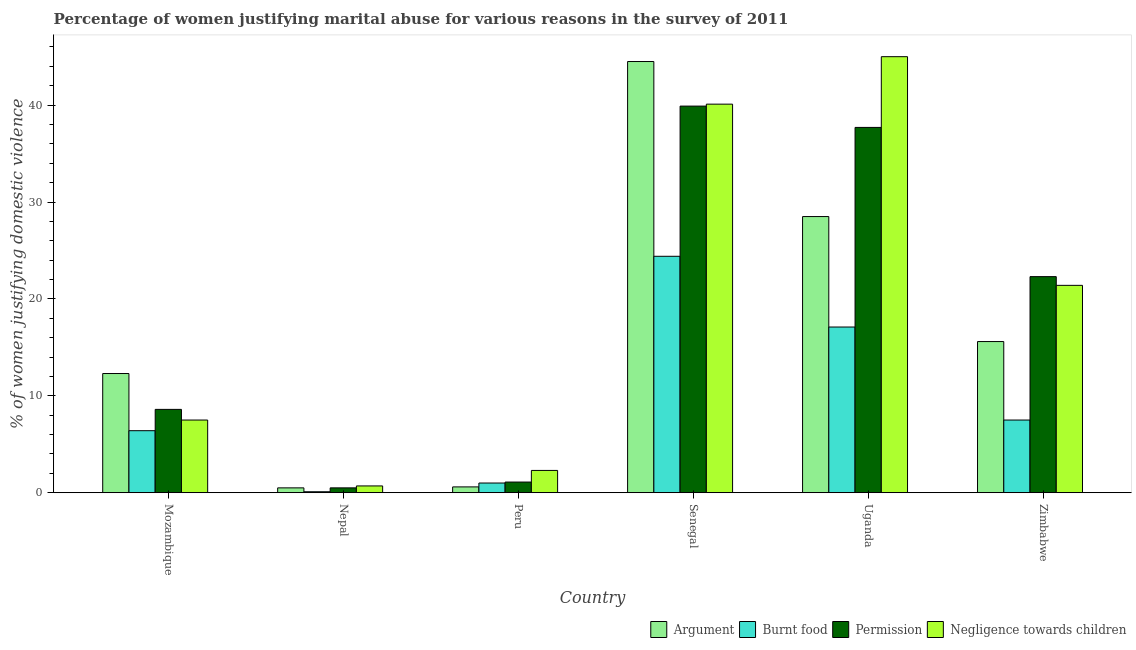Are the number of bars on each tick of the X-axis equal?
Provide a succinct answer. Yes. What is the label of the 5th group of bars from the left?
Provide a short and direct response. Uganda. In how many cases, is the number of bars for a given country not equal to the number of legend labels?
Give a very brief answer. 0. What is the percentage of women justifying abuse for burning food in Nepal?
Provide a succinct answer. 0.1. Across all countries, what is the minimum percentage of women justifying abuse for showing negligence towards children?
Provide a short and direct response. 0.7. In which country was the percentage of women justifying abuse for showing negligence towards children maximum?
Your response must be concise. Uganda. In which country was the percentage of women justifying abuse for burning food minimum?
Offer a very short reply. Nepal. What is the total percentage of women justifying abuse for showing negligence towards children in the graph?
Keep it short and to the point. 117. What is the difference between the percentage of women justifying abuse for burning food in Uganda and that in Zimbabwe?
Ensure brevity in your answer.  9.6. What is the difference between the percentage of women justifying abuse for burning food in Uganda and the percentage of women justifying abuse for showing negligence towards children in Zimbabwe?
Your response must be concise. -4.3. What is the average percentage of women justifying abuse for going without permission per country?
Provide a short and direct response. 18.35. In how many countries, is the percentage of women justifying abuse for going without permission greater than 6 %?
Offer a very short reply. 4. What is the ratio of the percentage of women justifying abuse in the case of an argument in Nepal to that in Uganda?
Your response must be concise. 0.02. Is the difference between the percentage of women justifying abuse for burning food in Uganda and Zimbabwe greater than the difference between the percentage of women justifying abuse in the case of an argument in Uganda and Zimbabwe?
Your answer should be compact. No. What is the difference between the highest and the second highest percentage of women justifying abuse for showing negligence towards children?
Your answer should be very brief. 4.9. What is the difference between the highest and the lowest percentage of women justifying abuse for showing negligence towards children?
Offer a very short reply. 44.3. Is it the case that in every country, the sum of the percentage of women justifying abuse for going without permission and percentage of women justifying abuse for showing negligence towards children is greater than the sum of percentage of women justifying abuse in the case of an argument and percentage of women justifying abuse for burning food?
Make the answer very short. No. What does the 3rd bar from the left in Peru represents?
Make the answer very short. Permission. What does the 2nd bar from the right in Peru represents?
Provide a short and direct response. Permission. Is it the case that in every country, the sum of the percentage of women justifying abuse in the case of an argument and percentage of women justifying abuse for burning food is greater than the percentage of women justifying abuse for going without permission?
Offer a terse response. Yes. How many bars are there?
Ensure brevity in your answer.  24. Are all the bars in the graph horizontal?
Your answer should be very brief. No. Where does the legend appear in the graph?
Offer a terse response. Bottom right. What is the title of the graph?
Your answer should be very brief. Percentage of women justifying marital abuse for various reasons in the survey of 2011. What is the label or title of the Y-axis?
Your response must be concise. % of women justifying domestic violence. What is the % of women justifying domestic violence in Burnt food in Mozambique?
Ensure brevity in your answer.  6.4. What is the % of women justifying domestic violence in Permission in Mozambique?
Give a very brief answer. 8.6. What is the % of women justifying domestic violence of Argument in Nepal?
Give a very brief answer. 0.5. What is the % of women justifying domestic violence in Permission in Nepal?
Offer a very short reply. 0.5. What is the % of women justifying domestic violence of Argument in Peru?
Your answer should be very brief. 0.6. What is the % of women justifying domestic violence of Permission in Peru?
Keep it short and to the point. 1.1. What is the % of women justifying domestic violence in Negligence towards children in Peru?
Offer a terse response. 2.3. What is the % of women justifying domestic violence in Argument in Senegal?
Offer a terse response. 44.5. What is the % of women justifying domestic violence in Burnt food in Senegal?
Provide a succinct answer. 24.4. What is the % of women justifying domestic violence in Permission in Senegal?
Keep it short and to the point. 39.9. What is the % of women justifying domestic violence of Negligence towards children in Senegal?
Offer a very short reply. 40.1. What is the % of women justifying domestic violence of Argument in Uganda?
Your response must be concise. 28.5. What is the % of women justifying domestic violence in Permission in Uganda?
Your response must be concise. 37.7. What is the % of women justifying domestic violence of Argument in Zimbabwe?
Give a very brief answer. 15.6. What is the % of women justifying domestic violence in Permission in Zimbabwe?
Provide a succinct answer. 22.3. What is the % of women justifying domestic violence of Negligence towards children in Zimbabwe?
Your response must be concise. 21.4. Across all countries, what is the maximum % of women justifying domestic violence in Argument?
Give a very brief answer. 44.5. Across all countries, what is the maximum % of women justifying domestic violence in Burnt food?
Your response must be concise. 24.4. Across all countries, what is the maximum % of women justifying domestic violence of Permission?
Keep it short and to the point. 39.9. Across all countries, what is the maximum % of women justifying domestic violence of Negligence towards children?
Provide a short and direct response. 45. Across all countries, what is the minimum % of women justifying domestic violence of Argument?
Provide a short and direct response. 0.5. Across all countries, what is the minimum % of women justifying domestic violence in Burnt food?
Give a very brief answer. 0.1. Across all countries, what is the minimum % of women justifying domestic violence in Permission?
Offer a terse response. 0.5. Across all countries, what is the minimum % of women justifying domestic violence in Negligence towards children?
Ensure brevity in your answer.  0.7. What is the total % of women justifying domestic violence in Argument in the graph?
Keep it short and to the point. 102. What is the total % of women justifying domestic violence of Burnt food in the graph?
Your response must be concise. 56.5. What is the total % of women justifying domestic violence in Permission in the graph?
Give a very brief answer. 110.1. What is the total % of women justifying domestic violence of Negligence towards children in the graph?
Provide a succinct answer. 117. What is the difference between the % of women justifying domestic violence of Burnt food in Mozambique and that in Nepal?
Offer a very short reply. 6.3. What is the difference between the % of women justifying domestic violence in Permission in Mozambique and that in Nepal?
Your response must be concise. 8.1. What is the difference between the % of women justifying domestic violence in Burnt food in Mozambique and that in Peru?
Give a very brief answer. 5.4. What is the difference between the % of women justifying domestic violence of Permission in Mozambique and that in Peru?
Your answer should be compact. 7.5. What is the difference between the % of women justifying domestic violence of Argument in Mozambique and that in Senegal?
Provide a short and direct response. -32.2. What is the difference between the % of women justifying domestic violence of Burnt food in Mozambique and that in Senegal?
Provide a short and direct response. -18. What is the difference between the % of women justifying domestic violence in Permission in Mozambique and that in Senegal?
Keep it short and to the point. -31.3. What is the difference between the % of women justifying domestic violence of Negligence towards children in Mozambique and that in Senegal?
Ensure brevity in your answer.  -32.6. What is the difference between the % of women justifying domestic violence of Argument in Mozambique and that in Uganda?
Provide a succinct answer. -16.2. What is the difference between the % of women justifying domestic violence in Permission in Mozambique and that in Uganda?
Provide a succinct answer. -29.1. What is the difference between the % of women justifying domestic violence in Negligence towards children in Mozambique and that in Uganda?
Your response must be concise. -37.5. What is the difference between the % of women justifying domestic violence in Argument in Mozambique and that in Zimbabwe?
Your answer should be very brief. -3.3. What is the difference between the % of women justifying domestic violence of Burnt food in Mozambique and that in Zimbabwe?
Provide a succinct answer. -1.1. What is the difference between the % of women justifying domestic violence of Permission in Mozambique and that in Zimbabwe?
Offer a terse response. -13.7. What is the difference between the % of women justifying domestic violence in Negligence towards children in Mozambique and that in Zimbabwe?
Keep it short and to the point. -13.9. What is the difference between the % of women justifying domestic violence of Burnt food in Nepal and that in Peru?
Your answer should be very brief. -0.9. What is the difference between the % of women justifying domestic violence in Negligence towards children in Nepal and that in Peru?
Your answer should be very brief. -1.6. What is the difference between the % of women justifying domestic violence in Argument in Nepal and that in Senegal?
Your answer should be very brief. -44. What is the difference between the % of women justifying domestic violence in Burnt food in Nepal and that in Senegal?
Give a very brief answer. -24.3. What is the difference between the % of women justifying domestic violence of Permission in Nepal and that in Senegal?
Your response must be concise. -39.4. What is the difference between the % of women justifying domestic violence of Negligence towards children in Nepal and that in Senegal?
Ensure brevity in your answer.  -39.4. What is the difference between the % of women justifying domestic violence of Argument in Nepal and that in Uganda?
Provide a short and direct response. -28. What is the difference between the % of women justifying domestic violence of Permission in Nepal and that in Uganda?
Give a very brief answer. -37.2. What is the difference between the % of women justifying domestic violence of Negligence towards children in Nepal and that in Uganda?
Your answer should be compact. -44.3. What is the difference between the % of women justifying domestic violence in Argument in Nepal and that in Zimbabwe?
Make the answer very short. -15.1. What is the difference between the % of women justifying domestic violence of Burnt food in Nepal and that in Zimbabwe?
Offer a very short reply. -7.4. What is the difference between the % of women justifying domestic violence of Permission in Nepal and that in Zimbabwe?
Make the answer very short. -21.8. What is the difference between the % of women justifying domestic violence in Negligence towards children in Nepal and that in Zimbabwe?
Ensure brevity in your answer.  -20.7. What is the difference between the % of women justifying domestic violence in Argument in Peru and that in Senegal?
Keep it short and to the point. -43.9. What is the difference between the % of women justifying domestic violence of Burnt food in Peru and that in Senegal?
Offer a terse response. -23.4. What is the difference between the % of women justifying domestic violence in Permission in Peru and that in Senegal?
Make the answer very short. -38.8. What is the difference between the % of women justifying domestic violence in Negligence towards children in Peru and that in Senegal?
Your response must be concise. -37.8. What is the difference between the % of women justifying domestic violence in Argument in Peru and that in Uganda?
Provide a succinct answer. -27.9. What is the difference between the % of women justifying domestic violence in Burnt food in Peru and that in Uganda?
Keep it short and to the point. -16.1. What is the difference between the % of women justifying domestic violence of Permission in Peru and that in Uganda?
Make the answer very short. -36.6. What is the difference between the % of women justifying domestic violence of Negligence towards children in Peru and that in Uganda?
Your response must be concise. -42.7. What is the difference between the % of women justifying domestic violence of Permission in Peru and that in Zimbabwe?
Provide a short and direct response. -21.2. What is the difference between the % of women justifying domestic violence in Negligence towards children in Peru and that in Zimbabwe?
Your response must be concise. -19.1. What is the difference between the % of women justifying domestic violence in Argument in Senegal and that in Uganda?
Make the answer very short. 16. What is the difference between the % of women justifying domestic violence in Argument in Senegal and that in Zimbabwe?
Offer a terse response. 28.9. What is the difference between the % of women justifying domestic violence in Permission in Senegal and that in Zimbabwe?
Offer a terse response. 17.6. What is the difference between the % of women justifying domestic violence in Negligence towards children in Senegal and that in Zimbabwe?
Provide a succinct answer. 18.7. What is the difference between the % of women justifying domestic violence of Burnt food in Uganda and that in Zimbabwe?
Make the answer very short. 9.6. What is the difference between the % of women justifying domestic violence of Permission in Uganda and that in Zimbabwe?
Your answer should be compact. 15.4. What is the difference between the % of women justifying domestic violence of Negligence towards children in Uganda and that in Zimbabwe?
Offer a terse response. 23.6. What is the difference between the % of women justifying domestic violence of Permission in Mozambique and the % of women justifying domestic violence of Negligence towards children in Nepal?
Provide a succinct answer. 7.9. What is the difference between the % of women justifying domestic violence in Argument in Mozambique and the % of women justifying domestic violence in Burnt food in Peru?
Your response must be concise. 11.3. What is the difference between the % of women justifying domestic violence in Permission in Mozambique and the % of women justifying domestic violence in Negligence towards children in Peru?
Provide a short and direct response. 6.3. What is the difference between the % of women justifying domestic violence in Argument in Mozambique and the % of women justifying domestic violence in Burnt food in Senegal?
Your answer should be very brief. -12.1. What is the difference between the % of women justifying domestic violence of Argument in Mozambique and the % of women justifying domestic violence of Permission in Senegal?
Keep it short and to the point. -27.6. What is the difference between the % of women justifying domestic violence of Argument in Mozambique and the % of women justifying domestic violence of Negligence towards children in Senegal?
Offer a terse response. -27.8. What is the difference between the % of women justifying domestic violence in Burnt food in Mozambique and the % of women justifying domestic violence in Permission in Senegal?
Your response must be concise. -33.5. What is the difference between the % of women justifying domestic violence of Burnt food in Mozambique and the % of women justifying domestic violence of Negligence towards children in Senegal?
Keep it short and to the point. -33.7. What is the difference between the % of women justifying domestic violence of Permission in Mozambique and the % of women justifying domestic violence of Negligence towards children in Senegal?
Give a very brief answer. -31.5. What is the difference between the % of women justifying domestic violence in Argument in Mozambique and the % of women justifying domestic violence in Permission in Uganda?
Offer a terse response. -25.4. What is the difference between the % of women justifying domestic violence of Argument in Mozambique and the % of women justifying domestic violence of Negligence towards children in Uganda?
Your answer should be compact. -32.7. What is the difference between the % of women justifying domestic violence in Burnt food in Mozambique and the % of women justifying domestic violence in Permission in Uganda?
Provide a succinct answer. -31.3. What is the difference between the % of women justifying domestic violence in Burnt food in Mozambique and the % of women justifying domestic violence in Negligence towards children in Uganda?
Ensure brevity in your answer.  -38.6. What is the difference between the % of women justifying domestic violence in Permission in Mozambique and the % of women justifying domestic violence in Negligence towards children in Uganda?
Make the answer very short. -36.4. What is the difference between the % of women justifying domestic violence of Argument in Mozambique and the % of women justifying domestic violence of Permission in Zimbabwe?
Your response must be concise. -10. What is the difference between the % of women justifying domestic violence in Argument in Mozambique and the % of women justifying domestic violence in Negligence towards children in Zimbabwe?
Your answer should be very brief. -9.1. What is the difference between the % of women justifying domestic violence in Burnt food in Mozambique and the % of women justifying domestic violence in Permission in Zimbabwe?
Your answer should be very brief. -15.9. What is the difference between the % of women justifying domestic violence of Burnt food in Mozambique and the % of women justifying domestic violence of Negligence towards children in Zimbabwe?
Give a very brief answer. -15. What is the difference between the % of women justifying domestic violence in Argument in Nepal and the % of women justifying domestic violence in Negligence towards children in Peru?
Keep it short and to the point. -1.8. What is the difference between the % of women justifying domestic violence of Burnt food in Nepal and the % of women justifying domestic violence of Negligence towards children in Peru?
Offer a terse response. -2.2. What is the difference between the % of women justifying domestic violence of Argument in Nepal and the % of women justifying domestic violence of Burnt food in Senegal?
Provide a succinct answer. -23.9. What is the difference between the % of women justifying domestic violence in Argument in Nepal and the % of women justifying domestic violence in Permission in Senegal?
Provide a short and direct response. -39.4. What is the difference between the % of women justifying domestic violence in Argument in Nepal and the % of women justifying domestic violence in Negligence towards children in Senegal?
Provide a succinct answer. -39.6. What is the difference between the % of women justifying domestic violence of Burnt food in Nepal and the % of women justifying domestic violence of Permission in Senegal?
Offer a very short reply. -39.8. What is the difference between the % of women justifying domestic violence of Permission in Nepal and the % of women justifying domestic violence of Negligence towards children in Senegal?
Provide a succinct answer. -39.6. What is the difference between the % of women justifying domestic violence in Argument in Nepal and the % of women justifying domestic violence in Burnt food in Uganda?
Provide a short and direct response. -16.6. What is the difference between the % of women justifying domestic violence in Argument in Nepal and the % of women justifying domestic violence in Permission in Uganda?
Your response must be concise. -37.2. What is the difference between the % of women justifying domestic violence of Argument in Nepal and the % of women justifying domestic violence of Negligence towards children in Uganda?
Provide a short and direct response. -44.5. What is the difference between the % of women justifying domestic violence in Burnt food in Nepal and the % of women justifying domestic violence in Permission in Uganda?
Your response must be concise. -37.6. What is the difference between the % of women justifying domestic violence of Burnt food in Nepal and the % of women justifying domestic violence of Negligence towards children in Uganda?
Make the answer very short. -44.9. What is the difference between the % of women justifying domestic violence in Permission in Nepal and the % of women justifying domestic violence in Negligence towards children in Uganda?
Your answer should be compact. -44.5. What is the difference between the % of women justifying domestic violence in Argument in Nepal and the % of women justifying domestic violence in Permission in Zimbabwe?
Offer a terse response. -21.8. What is the difference between the % of women justifying domestic violence in Argument in Nepal and the % of women justifying domestic violence in Negligence towards children in Zimbabwe?
Your answer should be very brief. -20.9. What is the difference between the % of women justifying domestic violence of Burnt food in Nepal and the % of women justifying domestic violence of Permission in Zimbabwe?
Ensure brevity in your answer.  -22.2. What is the difference between the % of women justifying domestic violence in Burnt food in Nepal and the % of women justifying domestic violence in Negligence towards children in Zimbabwe?
Offer a terse response. -21.3. What is the difference between the % of women justifying domestic violence in Permission in Nepal and the % of women justifying domestic violence in Negligence towards children in Zimbabwe?
Keep it short and to the point. -20.9. What is the difference between the % of women justifying domestic violence of Argument in Peru and the % of women justifying domestic violence of Burnt food in Senegal?
Provide a succinct answer. -23.8. What is the difference between the % of women justifying domestic violence of Argument in Peru and the % of women justifying domestic violence of Permission in Senegal?
Your answer should be very brief. -39.3. What is the difference between the % of women justifying domestic violence of Argument in Peru and the % of women justifying domestic violence of Negligence towards children in Senegal?
Your answer should be very brief. -39.5. What is the difference between the % of women justifying domestic violence of Burnt food in Peru and the % of women justifying domestic violence of Permission in Senegal?
Keep it short and to the point. -38.9. What is the difference between the % of women justifying domestic violence in Burnt food in Peru and the % of women justifying domestic violence in Negligence towards children in Senegal?
Provide a succinct answer. -39.1. What is the difference between the % of women justifying domestic violence in Permission in Peru and the % of women justifying domestic violence in Negligence towards children in Senegal?
Offer a very short reply. -39. What is the difference between the % of women justifying domestic violence of Argument in Peru and the % of women justifying domestic violence of Burnt food in Uganda?
Offer a terse response. -16.5. What is the difference between the % of women justifying domestic violence of Argument in Peru and the % of women justifying domestic violence of Permission in Uganda?
Give a very brief answer. -37.1. What is the difference between the % of women justifying domestic violence in Argument in Peru and the % of women justifying domestic violence in Negligence towards children in Uganda?
Your response must be concise. -44.4. What is the difference between the % of women justifying domestic violence in Burnt food in Peru and the % of women justifying domestic violence in Permission in Uganda?
Make the answer very short. -36.7. What is the difference between the % of women justifying domestic violence in Burnt food in Peru and the % of women justifying domestic violence in Negligence towards children in Uganda?
Offer a terse response. -44. What is the difference between the % of women justifying domestic violence of Permission in Peru and the % of women justifying domestic violence of Negligence towards children in Uganda?
Provide a succinct answer. -43.9. What is the difference between the % of women justifying domestic violence in Argument in Peru and the % of women justifying domestic violence in Permission in Zimbabwe?
Your answer should be very brief. -21.7. What is the difference between the % of women justifying domestic violence of Argument in Peru and the % of women justifying domestic violence of Negligence towards children in Zimbabwe?
Your answer should be compact. -20.8. What is the difference between the % of women justifying domestic violence in Burnt food in Peru and the % of women justifying domestic violence in Permission in Zimbabwe?
Keep it short and to the point. -21.3. What is the difference between the % of women justifying domestic violence in Burnt food in Peru and the % of women justifying domestic violence in Negligence towards children in Zimbabwe?
Provide a succinct answer. -20.4. What is the difference between the % of women justifying domestic violence of Permission in Peru and the % of women justifying domestic violence of Negligence towards children in Zimbabwe?
Provide a short and direct response. -20.3. What is the difference between the % of women justifying domestic violence in Argument in Senegal and the % of women justifying domestic violence in Burnt food in Uganda?
Provide a succinct answer. 27.4. What is the difference between the % of women justifying domestic violence in Argument in Senegal and the % of women justifying domestic violence in Permission in Uganda?
Keep it short and to the point. 6.8. What is the difference between the % of women justifying domestic violence of Argument in Senegal and the % of women justifying domestic violence of Negligence towards children in Uganda?
Make the answer very short. -0.5. What is the difference between the % of women justifying domestic violence in Burnt food in Senegal and the % of women justifying domestic violence in Negligence towards children in Uganda?
Ensure brevity in your answer.  -20.6. What is the difference between the % of women justifying domestic violence in Argument in Senegal and the % of women justifying domestic violence in Burnt food in Zimbabwe?
Offer a terse response. 37. What is the difference between the % of women justifying domestic violence in Argument in Senegal and the % of women justifying domestic violence in Permission in Zimbabwe?
Make the answer very short. 22.2. What is the difference between the % of women justifying domestic violence in Argument in Senegal and the % of women justifying domestic violence in Negligence towards children in Zimbabwe?
Keep it short and to the point. 23.1. What is the difference between the % of women justifying domestic violence in Argument in Uganda and the % of women justifying domestic violence in Burnt food in Zimbabwe?
Provide a short and direct response. 21. What is the difference between the % of women justifying domestic violence in Argument in Uganda and the % of women justifying domestic violence in Permission in Zimbabwe?
Make the answer very short. 6.2. What is the difference between the % of women justifying domestic violence in Argument in Uganda and the % of women justifying domestic violence in Negligence towards children in Zimbabwe?
Your answer should be compact. 7.1. What is the difference between the % of women justifying domestic violence of Burnt food in Uganda and the % of women justifying domestic violence of Permission in Zimbabwe?
Provide a succinct answer. -5.2. What is the difference between the % of women justifying domestic violence in Burnt food in Uganda and the % of women justifying domestic violence in Negligence towards children in Zimbabwe?
Give a very brief answer. -4.3. What is the difference between the % of women justifying domestic violence of Permission in Uganda and the % of women justifying domestic violence of Negligence towards children in Zimbabwe?
Your answer should be very brief. 16.3. What is the average % of women justifying domestic violence in Burnt food per country?
Your answer should be compact. 9.42. What is the average % of women justifying domestic violence in Permission per country?
Offer a terse response. 18.35. What is the average % of women justifying domestic violence in Negligence towards children per country?
Ensure brevity in your answer.  19.5. What is the difference between the % of women justifying domestic violence of Argument and % of women justifying domestic violence of Permission in Mozambique?
Provide a succinct answer. 3.7. What is the difference between the % of women justifying domestic violence of Burnt food and % of women justifying domestic violence of Permission in Mozambique?
Your answer should be very brief. -2.2. What is the difference between the % of women justifying domestic violence in Argument and % of women justifying domestic violence in Burnt food in Nepal?
Make the answer very short. 0.4. What is the difference between the % of women justifying domestic violence of Argument and % of women justifying domestic violence of Negligence towards children in Peru?
Your answer should be very brief. -1.7. What is the difference between the % of women justifying domestic violence in Burnt food and % of women justifying domestic violence in Negligence towards children in Peru?
Offer a terse response. -1.3. What is the difference between the % of women justifying domestic violence of Argument and % of women justifying domestic violence of Burnt food in Senegal?
Give a very brief answer. 20.1. What is the difference between the % of women justifying domestic violence in Argument and % of women justifying domestic violence in Negligence towards children in Senegal?
Make the answer very short. 4.4. What is the difference between the % of women justifying domestic violence of Burnt food and % of women justifying domestic violence of Permission in Senegal?
Your answer should be compact. -15.5. What is the difference between the % of women justifying domestic violence in Burnt food and % of women justifying domestic violence in Negligence towards children in Senegal?
Offer a very short reply. -15.7. What is the difference between the % of women justifying domestic violence in Permission and % of women justifying domestic violence in Negligence towards children in Senegal?
Provide a succinct answer. -0.2. What is the difference between the % of women justifying domestic violence of Argument and % of women justifying domestic violence of Burnt food in Uganda?
Offer a terse response. 11.4. What is the difference between the % of women justifying domestic violence in Argument and % of women justifying domestic violence in Permission in Uganda?
Your answer should be compact. -9.2. What is the difference between the % of women justifying domestic violence in Argument and % of women justifying domestic violence in Negligence towards children in Uganda?
Offer a very short reply. -16.5. What is the difference between the % of women justifying domestic violence of Burnt food and % of women justifying domestic violence of Permission in Uganda?
Make the answer very short. -20.6. What is the difference between the % of women justifying domestic violence in Burnt food and % of women justifying domestic violence in Negligence towards children in Uganda?
Your answer should be compact. -27.9. What is the difference between the % of women justifying domestic violence in Argument and % of women justifying domestic violence in Burnt food in Zimbabwe?
Offer a very short reply. 8.1. What is the difference between the % of women justifying domestic violence in Argument and % of women justifying domestic violence in Negligence towards children in Zimbabwe?
Make the answer very short. -5.8. What is the difference between the % of women justifying domestic violence of Burnt food and % of women justifying domestic violence of Permission in Zimbabwe?
Your response must be concise. -14.8. What is the difference between the % of women justifying domestic violence of Burnt food and % of women justifying domestic violence of Negligence towards children in Zimbabwe?
Make the answer very short. -13.9. What is the difference between the % of women justifying domestic violence of Permission and % of women justifying domestic violence of Negligence towards children in Zimbabwe?
Offer a very short reply. 0.9. What is the ratio of the % of women justifying domestic violence of Argument in Mozambique to that in Nepal?
Your answer should be very brief. 24.6. What is the ratio of the % of women justifying domestic violence in Negligence towards children in Mozambique to that in Nepal?
Your answer should be very brief. 10.71. What is the ratio of the % of women justifying domestic violence of Permission in Mozambique to that in Peru?
Your answer should be compact. 7.82. What is the ratio of the % of women justifying domestic violence in Negligence towards children in Mozambique to that in Peru?
Your response must be concise. 3.26. What is the ratio of the % of women justifying domestic violence in Argument in Mozambique to that in Senegal?
Offer a very short reply. 0.28. What is the ratio of the % of women justifying domestic violence of Burnt food in Mozambique to that in Senegal?
Your answer should be very brief. 0.26. What is the ratio of the % of women justifying domestic violence of Permission in Mozambique to that in Senegal?
Your response must be concise. 0.22. What is the ratio of the % of women justifying domestic violence of Negligence towards children in Mozambique to that in Senegal?
Give a very brief answer. 0.19. What is the ratio of the % of women justifying domestic violence in Argument in Mozambique to that in Uganda?
Provide a succinct answer. 0.43. What is the ratio of the % of women justifying domestic violence in Burnt food in Mozambique to that in Uganda?
Your response must be concise. 0.37. What is the ratio of the % of women justifying domestic violence of Permission in Mozambique to that in Uganda?
Your response must be concise. 0.23. What is the ratio of the % of women justifying domestic violence in Argument in Mozambique to that in Zimbabwe?
Give a very brief answer. 0.79. What is the ratio of the % of women justifying domestic violence of Burnt food in Mozambique to that in Zimbabwe?
Give a very brief answer. 0.85. What is the ratio of the % of women justifying domestic violence in Permission in Mozambique to that in Zimbabwe?
Provide a short and direct response. 0.39. What is the ratio of the % of women justifying domestic violence in Negligence towards children in Mozambique to that in Zimbabwe?
Give a very brief answer. 0.35. What is the ratio of the % of women justifying domestic violence of Argument in Nepal to that in Peru?
Provide a short and direct response. 0.83. What is the ratio of the % of women justifying domestic violence in Permission in Nepal to that in Peru?
Make the answer very short. 0.45. What is the ratio of the % of women justifying domestic violence of Negligence towards children in Nepal to that in Peru?
Your answer should be very brief. 0.3. What is the ratio of the % of women justifying domestic violence of Argument in Nepal to that in Senegal?
Offer a very short reply. 0.01. What is the ratio of the % of women justifying domestic violence of Burnt food in Nepal to that in Senegal?
Your answer should be very brief. 0. What is the ratio of the % of women justifying domestic violence in Permission in Nepal to that in Senegal?
Ensure brevity in your answer.  0.01. What is the ratio of the % of women justifying domestic violence of Negligence towards children in Nepal to that in Senegal?
Ensure brevity in your answer.  0.02. What is the ratio of the % of women justifying domestic violence of Argument in Nepal to that in Uganda?
Offer a very short reply. 0.02. What is the ratio of the % of women justifying domestic violence in Burnt food in Nepal to that in Uganda?
Your response must be concise. 0.01. What is the ratio of the % of women justifying domestic violence in Permission in Nepal to that in Uganda?
Your answer should be compact. 0.01. What is the ratio of the % of women justifying domestic violence of Negligence towards children in Nepal to that in Uganda?
Give a very brief answer. 0.02. What is the ratio of the % of women justifying domestic violence of Argument in Nepal to that in Zimbabwe?
Keep it short and to the point. 0.03. What is the ratio of the % of women justifying domestic violence in Burnt food in Nepal to that in Zimbabwe?
Offer a terse response. 0.01. What is the ratio of the % of women justifying domestic violence of Permission in Nepal to that in Zimbabwe?
Your answer should be very brief. 0.02. What is the ratio of the % of women justifying domestic violence of Negligence towards children in Nepal to that in Zimbabwe?
Offer a terse response. 0.03. What is the ratio of the % of women justifying domestic violence in Argument in Peru to that in Senegal?
Your answer should be compact. 0.01. What is the ratio of the % of women justifying domestic violence in Burnt food in Peru to that in Senegal?
Ensure brevity in your answer.  0.04. What is the ratio of the % of women justifying domestic violence of Permission in Peru to that in Senegal?
Keep it short and to the point. 0.03. What is the ratio of the % of women justifying domestic violence of Negligence towards children in Peru to that in Senegal?
Keep it short and to the point. 0.06. What is the ratio of the % of women justifying domestic violence of Argument in Peru to that in Uganda?
Make the answer very short. 0.02. What is the ratio of the % of women justifying domestic violence in Burnt food in Peru to that in Uganda?
Your answer should be very brief. 0.06. What is the ratio of the % of women justifying domestic violence of Permission in Peru to that in Uganda?
Your answer should be compact. 0.03. What is the ratio of the % of women justifying domestic violence in Negligence towards children in Peru to that in Uganda?
Give a very brief answer. 0.05. What is the ratio of the % of women justifying domestic violence of Argument in Peru to that in Zimbabwe?
Provide a short and direct response. 0.04. What is the ratio of the % of women justifying domestic violence of Burnt food in Peru to that in Zimbabwe?
Keep it short and to the point. 0.13. What is the ratio of the % of women justifying domestic violence of Permission in Peru to that in Zimbabwe?
Provide a succinct answer. 0.05. What is the ratio of the % of women justifying domestic violence of Negligence towards children in Peru to that in Zimbabwe?
Ensure brevity in your answer.  0.11. What is the ratio of the % of women justifying domestic violence in Argument in Senegal to that in Uganda?
Keep it short and to the point. 1.56. What is the ratio of the % of women justifying domestic violence in Burnt food in Senegal to that in Uganda?
Give a very brief answer. 1.43. What is the ratio of the % of women justifying domestic violence in Permission in Senegal to that in Uganda?
Ensure brevity in your answer.  1.06. What is the ratio of the % of women justifying domestic violence in Negligence towards children in Senegal to that in Uganda?
Ensure brevity in your answer.  0.89. What is the ratio of the % of women justifying domestic violence in Argument in Senegal to that in Zimbabwe?
Provide a succinct answer. 2.85. What is the ratio of the % of women justifying domestic violence of Burnt food in Senegal to that in Zimbabwe?
Give a very brief answer. 3.25. What is the ratio of the % of women justifying domestic violence of Permission in Senegal to that in Zimbabwe?
Your answer should be very brief. 1.79. What is the ratio of the % of women justifying domestic violence of Negligence towards children in Senegal to that in Zimbabwe?
Your response must be concise. 1.87. What is the ratio of the % of women justifying domestic violence of Argument in Uganda to that in Zimbabwe?
Offer a terse response. 1.83. What is the ratio of the % of women justifying domestic violence of Burnt food in Uganda to that in Zimbabwe?
Your answer should be compact. 2.28. What is the ratio of the % of women justifying domestic violence in Permission in Uganda to that in Zimbabwe?
Your response must be concise. 1.69. What is the ratio of the % of women justifying domestic violence of Negligence towards children in Uganda to that in Zimbabwe?
Offer a very short reply. 2.1. What is the difference between the highest and the second highest % of women justifying domestic violence in Argument?
Keep it short and to the point. 16. What is the difference between the highest and the second highest % of women justifying domestic violence of Negligence towards children?
Give a very brief answer. 4.9. What is the difference between the highest and the lowest % of women justifying domestic violence of Argument?
Your answer should be compact. 44. What is the difference between the highest and the lowest % of women justifying domestic violence of Burnt food?
Keep it short and to the point. 24.3. What is the difference between the highest and the lowest % of women justifying domestic violence in Permission?
Provide a succinct answer. 39.4. What is the difference between the highest and the lowest % of women justifying domestic violence of Negligence towards children?
Give a very brief answer. 44.3. 